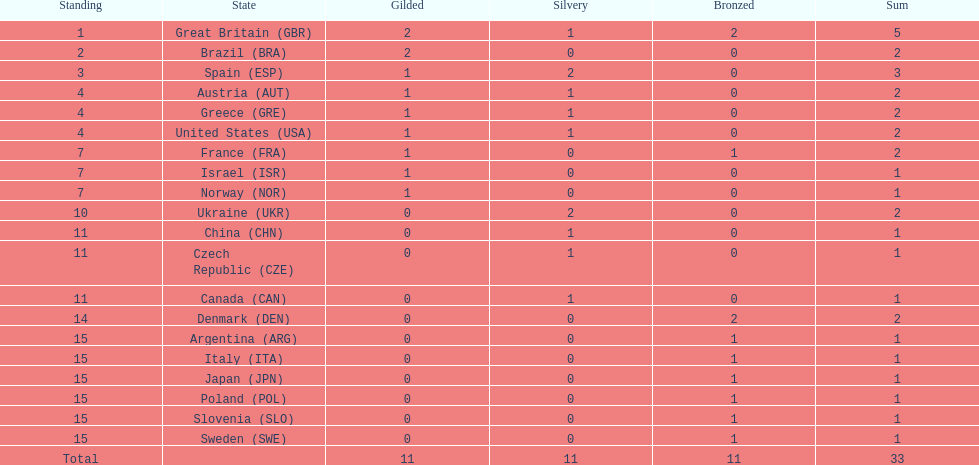What is the overall count of medals secured by the united states? 2. 